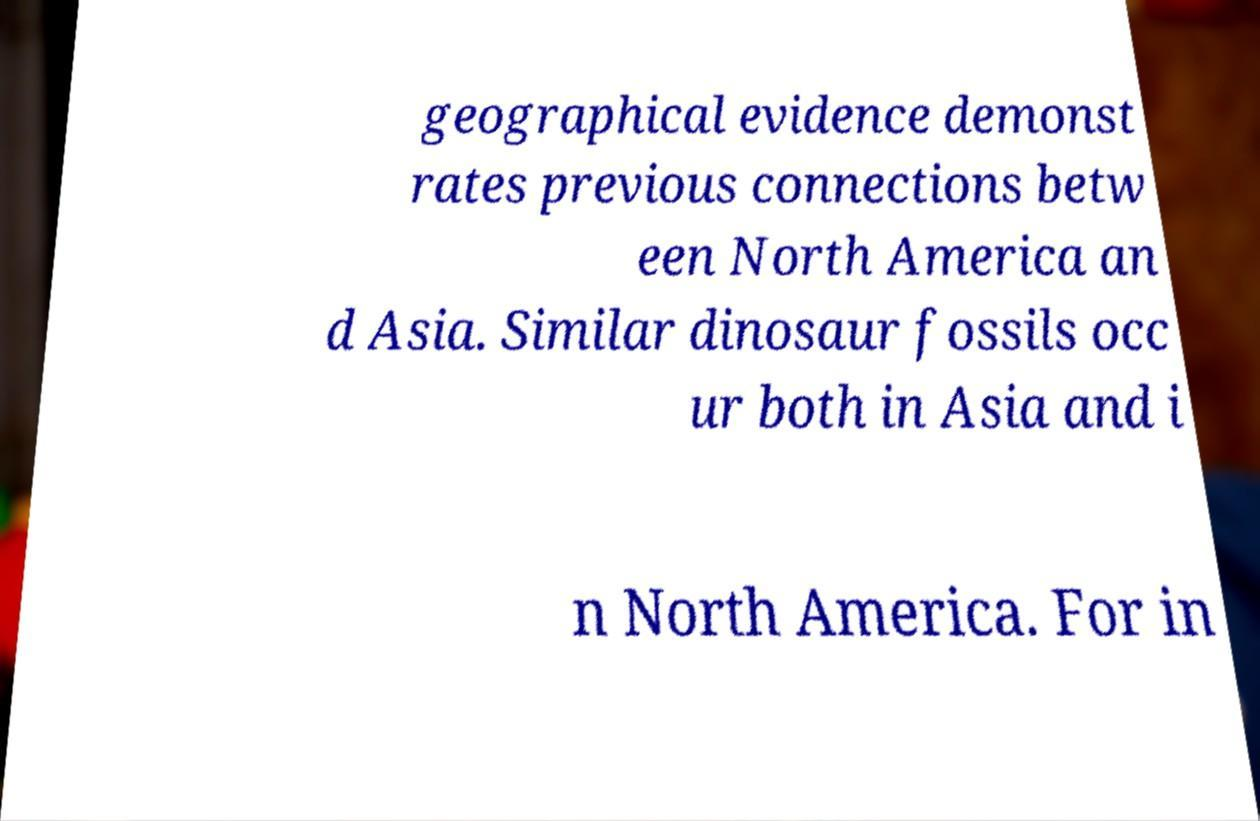Can you read and provide the text displayed in the image?This photo seems to have some interesting text. Can you extract and type it out for me? geographical evidence demonst rates previous connections betw een North America an d Asia. Similar dinosaur fossils occ ur both in Asia and i n North America. For in 